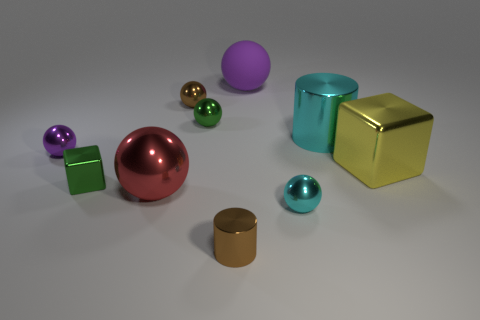Subtract all purple shiny balls. How many balls are left? 5 Subtract all red cubes. How many purple spheres are left? 2 Subtract all green balls. How many balls are left? 5 Subtract all green spheres. Subtract all red blocks. How many spheres are left? 5 Subtract all balls. How many objects are left? 4 Subtract all cyan matte cylinders. Subtract all small brown metallic cylinders. How many objects are left? 9 Add 2 big red things. How many big red things are left? 3 Add 8 large spheres. How many large spheres exist? 10 Subtract 0 blue spheres. How many objects are left? 10 